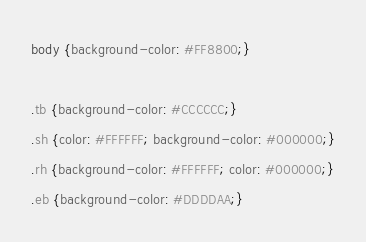<code> <loc_0><loc_0><loc_500><loc_500><_CSS_>body {background-color: #FF8800;}

.tb {background-color: #CCCCCC;}
.sh {color: #FFFFFF; background-color: #000000;}
.rh {background-color: #FFFFFF; color: #000000;}
.eb {background-color: #DDDDAA;}

</code> 